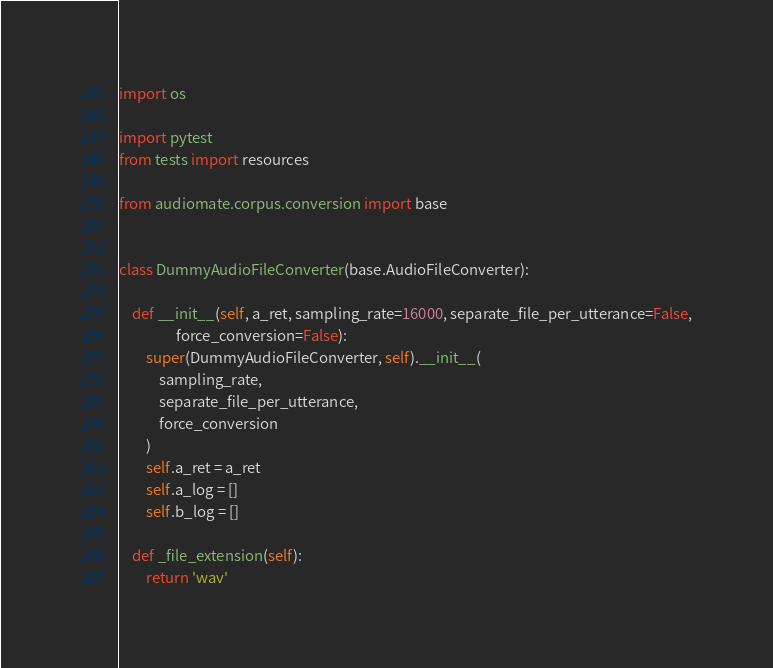Convert code to text. <code><loc_0><loc_0><loc_500><loc_500><_Python_>import os

import pytest
from tests import resources

from audiomate.corpus.conversion import base


class DummyAudioFileConverter(base.AudioFileConverter):

    def __init__(self, a_ret, sampling_rate=16000, separate_file_per_utterance=False,
                 force_conversion=False):
        super(DummyAudioFileConverter, self).__init__(
            sampling_rate,
            separate_file_per_utterance,
            force_conversion
        )
        self.a_ret = a_ret
        self.a_log = []
        self.b_log = []

    def _file_extension(self):
        return 'wav'
</code> 